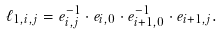Convert formula to latex. <formula><loc_0><loc_0><loc_500><loc_500>\ell _ { 1 , i , j } = e _ { i , j } ^ { - 1 } \cdot e _ { i , 0 } \cdot e _ { i + 1 , 0 } ^ { - 1 } \cdot e _ { i + 1 , j } .</formula> 